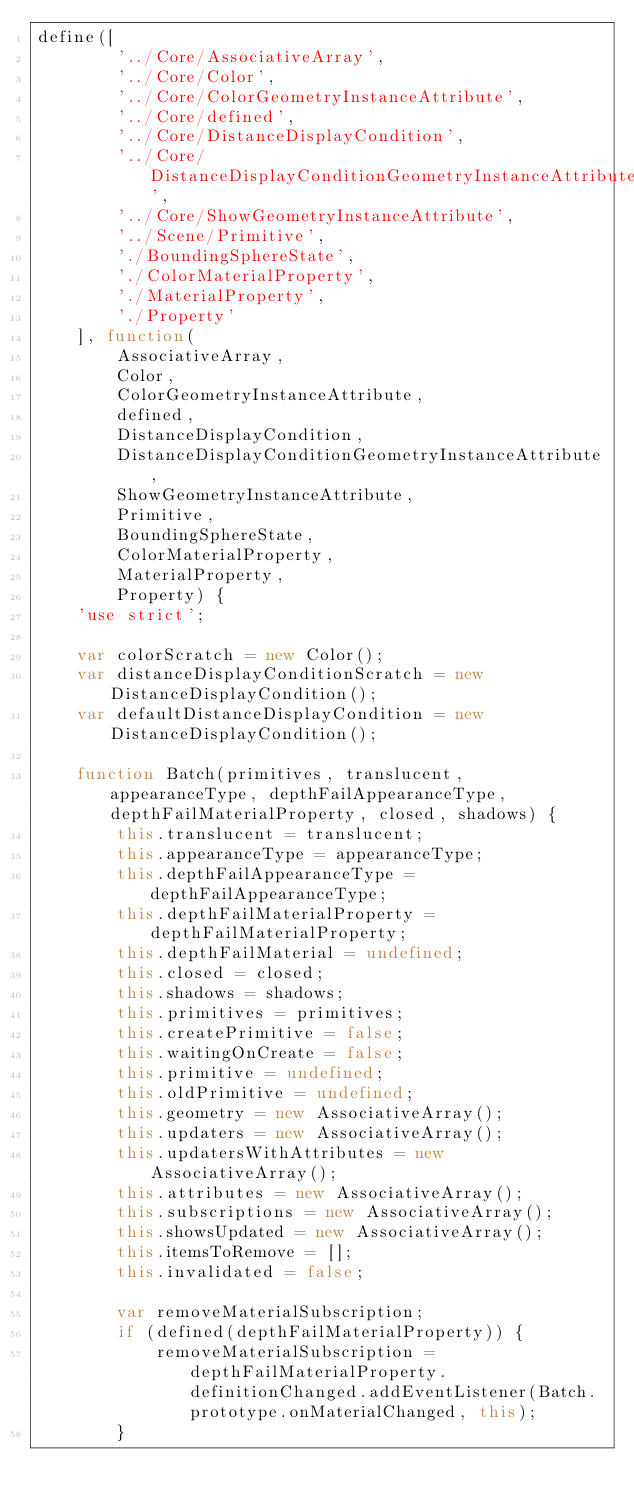<code> <loc_0><loc_0><loc_500><loc_500><_JavaScript_>define([
        '../Core/AssociativeArray',
        '../Core/Color',
        '../Core/ColorGeometryInstanceAttribute',
        '../Core/defined',
        '../Core/DistanceDisplayCondition',
        '../Core/DistanceDisplayConditionGeometryInstanceAttribute',
        '../Core/ShowGeometryInstanceAttribute',
        '../Scene/Primitive',
        './BoundingSphereState',
        './ColorMaterialProperty',
        './MaterialProperty',
        './Property'
    ], function(
        AssociativeArray,
        Color,
        ColorGeometryInstanceAttribute,
        defined,
        DistanceDisplayCondition,
        DistanceDisplayConditionGeometryInstanceAttribute,
        ShowGeometryInstanceAttribute,
        Primitive,
        BoundingSphereState,
        ColorMaterialProperty,
        MaterialProperty,
        Property) {
    'use strict';

    var colorScratch = new Color();
    var distanceDisplayConditionScratch = new DistanceDisplayCondition();
    var defaultDistanceDisplayCondition = new DistanceDisplayCondition();

    function Batch(primitives, translucent, appearanceType, depthFailAppearanceType, depthFailMaterialProperty, closed, shadows) {
        this.translucent = translucent;
        this.appearanceType = appearanceType;
        this.depthFailAppearanceType = depthFailAppearanceType;
        this.depthFailMaterialProperty = depthFailMaterialProperty;
        this.depthFailMaterial = undefined;
        this.closed = closed;
        this.shadows = shadows;
        this.primitives = primitives;
        this.createPrimitive = false;
        this.waitingOnCreate = false;
        this.primitive = undefined;
        this.oldPrimitive = undefined;
        this.geometry = new AssociativeArray();
        this.updaters = new AssociativeArray();
        this.updatersWithAttributes = new AssociativeArray();
        this.attributes = new AssociativeArray();
        this.subscriptions = new AssociativeArray();
        this.showsUpdated = new AssociativeArray();
        this.itemsToRemove = [];
        this.invalidated = false;

        var removeMaterialSubscription;
        if (defined(depthFailMaterialProperty)) {
            removeMaterialSubscription = depthFailMaterialProperty.definitionChanged.addEventListener(Batch.prototype.onMaterialChanged, this);
        }</code> 